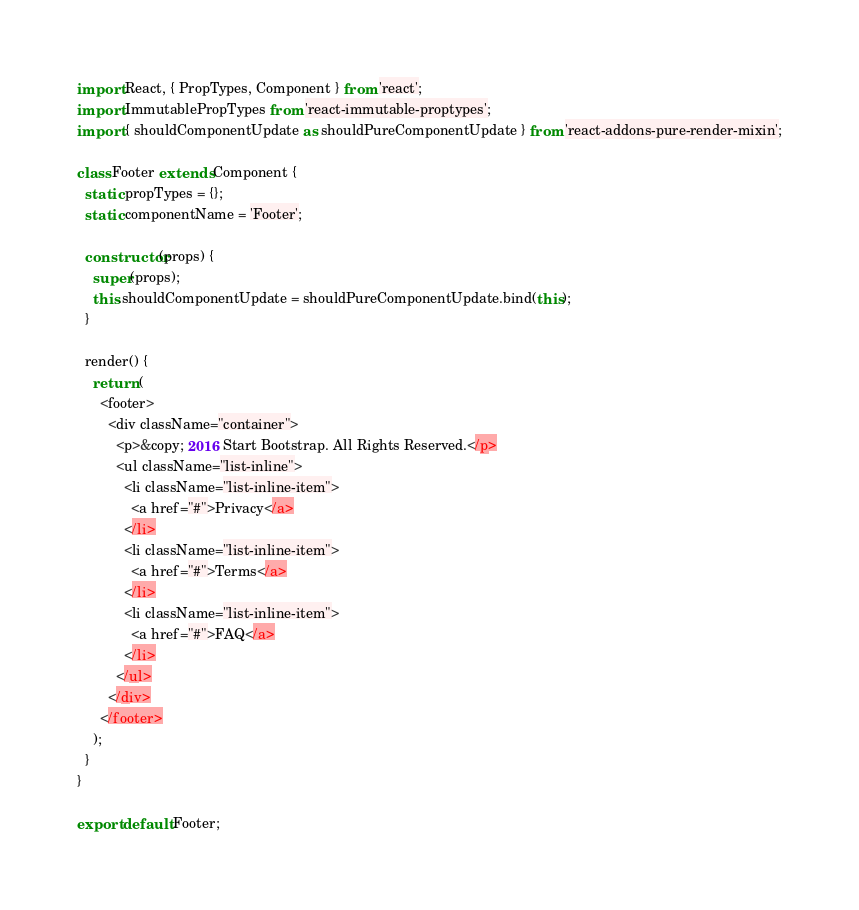<code> <loc_0><loc_0><loc_500><loc_500><_JavaScript_>import React, { PropTypes, Component } from 'react';
import ImmutablePropTypes from 'react-immutable-proptypes';
import { shouldComponentUpdate as shouldPureComponentUpdate } from 'react-addons-pure-render-mixin';

class Footer extends Component {
  static propTypes = {};
  static componentName = 'Footer';

  constructor(props) {
    super(props);
    this.shouldComponentUpdate = shouldPureComponentUpdate.bind(this);
  }

  render() {
    return (
      <footer>
        <div className="container">
          <p>&copy; 2016 Start Bootstrap. All Rights Reserved.</p>
          <ul className="list-inline">
            <li className="list-inline-item">
              <a href="#">Privacy</a>
            </li>
            <li className="list-inline-item">
              <a href="#">Terms</a>
            </li>
            <li className="list-inline-item">
              <a href="#">FAQ</a>
            </li>
          </ul>
        </div>
      </footer>
    );
  }
}

export default Footer;
</code> 